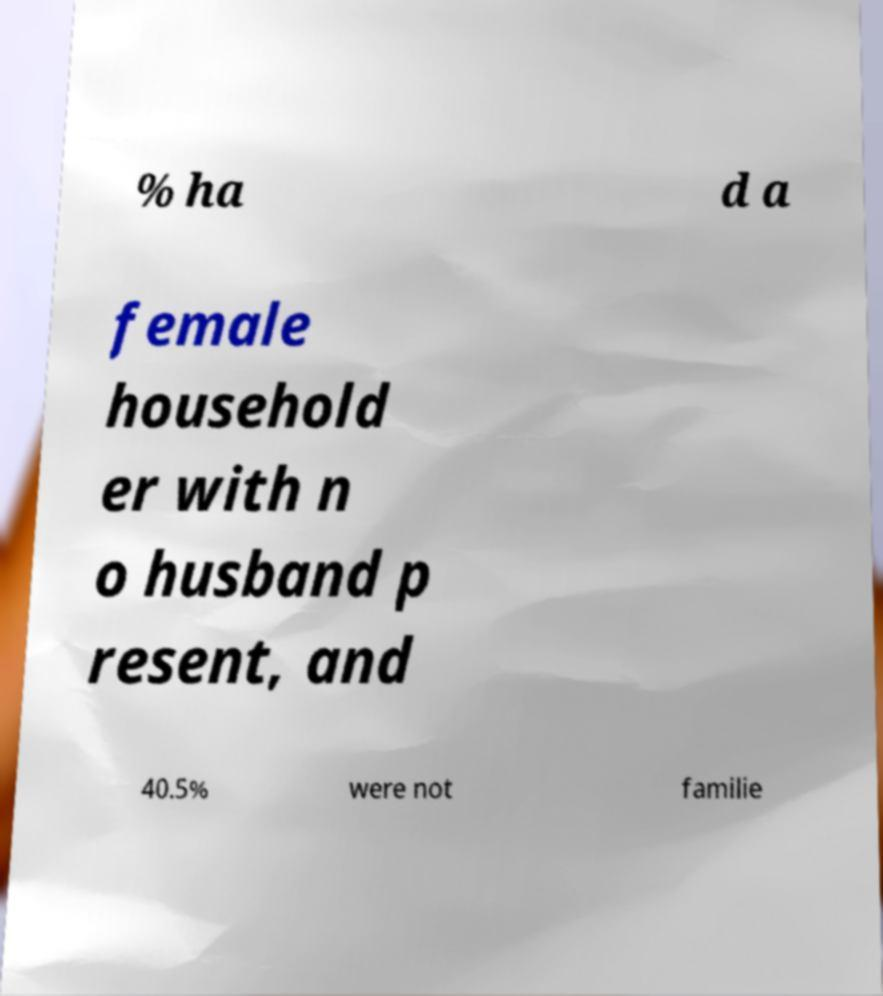What messages or text are displayed in this image? I need them in a readable, typed format. % ha d a female household er with n o husband p resent, and 40.5% were not familie 